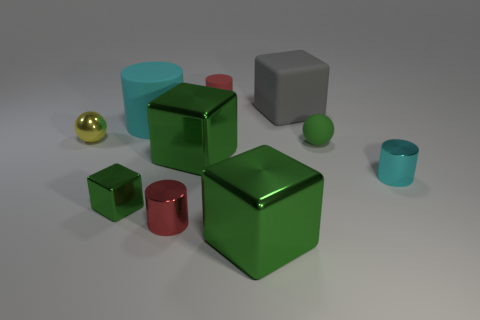Does the cyan cylinder behind the yellow metal ball have the same size as the small green metallic object?
Keep it short and to the point. No. There is a large object that is the same shape as the small red metallic thing; what is it made of?
Provide a short and direct response. Rubber. Do the tiny red metal thing and the yellow metal thing have the same shape?
Your response must be concise. No. How many matte spheres are behind the sphere that is to the right of the tiny green metallic thing?
Offer a very short reply. 0. What shape is the tiny green thing that is made of the same material as the small yellow object?
Make the answer very short. Cube. What number of blue objects are metal spheres or tiny things?
Provide a short and direct response. 0. Is there a shiny cylinder that is left of the big green metallic block behind the small cylinder right of the red matte thing?
Provide a succinct answer. Yes. Are there fewer large matte cylinders than blue metallic balls?
Give a very brief answer. No. There is a small red thing behind the large cyan cylinder; is its shape the same as the small green rubber object?
Make the answer very short. No. Are any spheres visible?
Your answer should be very brief. Yes. 